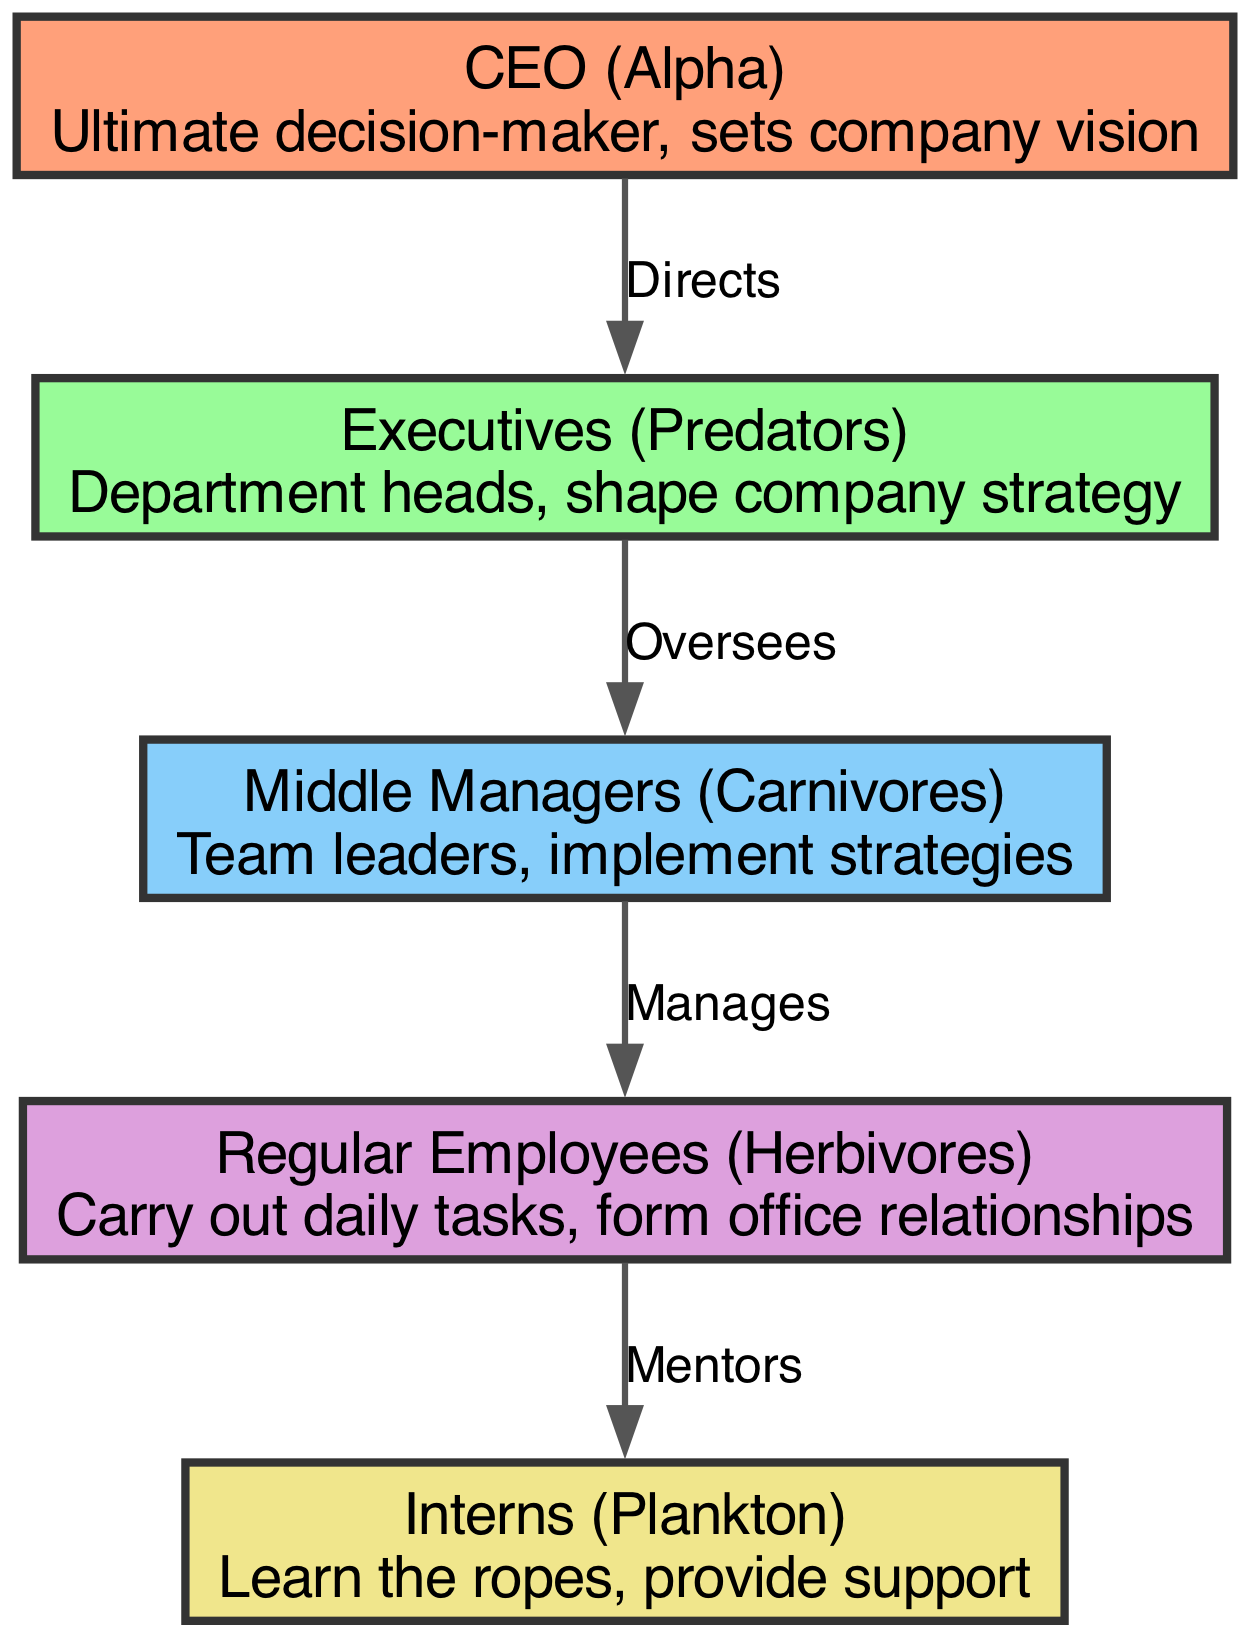What is the highest position in the corporate food chain? The highest position is represented by the node labeled "CEO (Alpha)," which indicates the ultimate decision-maker within the organization.
Answer: CEO (Alpha) How many nodes are there in the diagram? The diagram consists of five distinct nodes representing different roles within the corporate structure.
Answer: 5 What is the relationship between Executives and Middle Managers? The Executives oversee the Middle Managers, as indicated by the directed edge labeled "Oversees" connecting these two roles in the diagram.
Answer: Oversees Which group provides mentorship to the Interns? The Regular Employees are depicted as mentors to the Interns, according to the directed edge labeled "Mentors" in the diagram.
Answer: Regular Employees Who directly directs the Executives? The CEO is the one who directly directs the Executives, as shown by the edge from the CEO to the Executives labeled "Directs."
Answer: CEO What type of role do Middle Managers play in the corporate food chain? Middle Managers are identified as "Carnivores," which illustrates their active role in managing and implementing strategies within teams.
Answer: Carnivores What is the lowest level in the power dynamics of the office? The group identified as Interns represents the lowest level in the corporate hierarchy, similar to "Plankton" in a food chain context.
Answer: Interns How many edges connect the different levels in the corporate food chain? There are four distinct edges connecting the different nodes in the diagram, representing various relationships and responsibilities.
Answer: 4 What role is considered the ultimate decision-maker? The role identified as CEO (Alpha) is recognized as the ultimate decision-maker, indicating a position of highest authority and strategic vision in the company.
Answer: CEO (Alpha) 